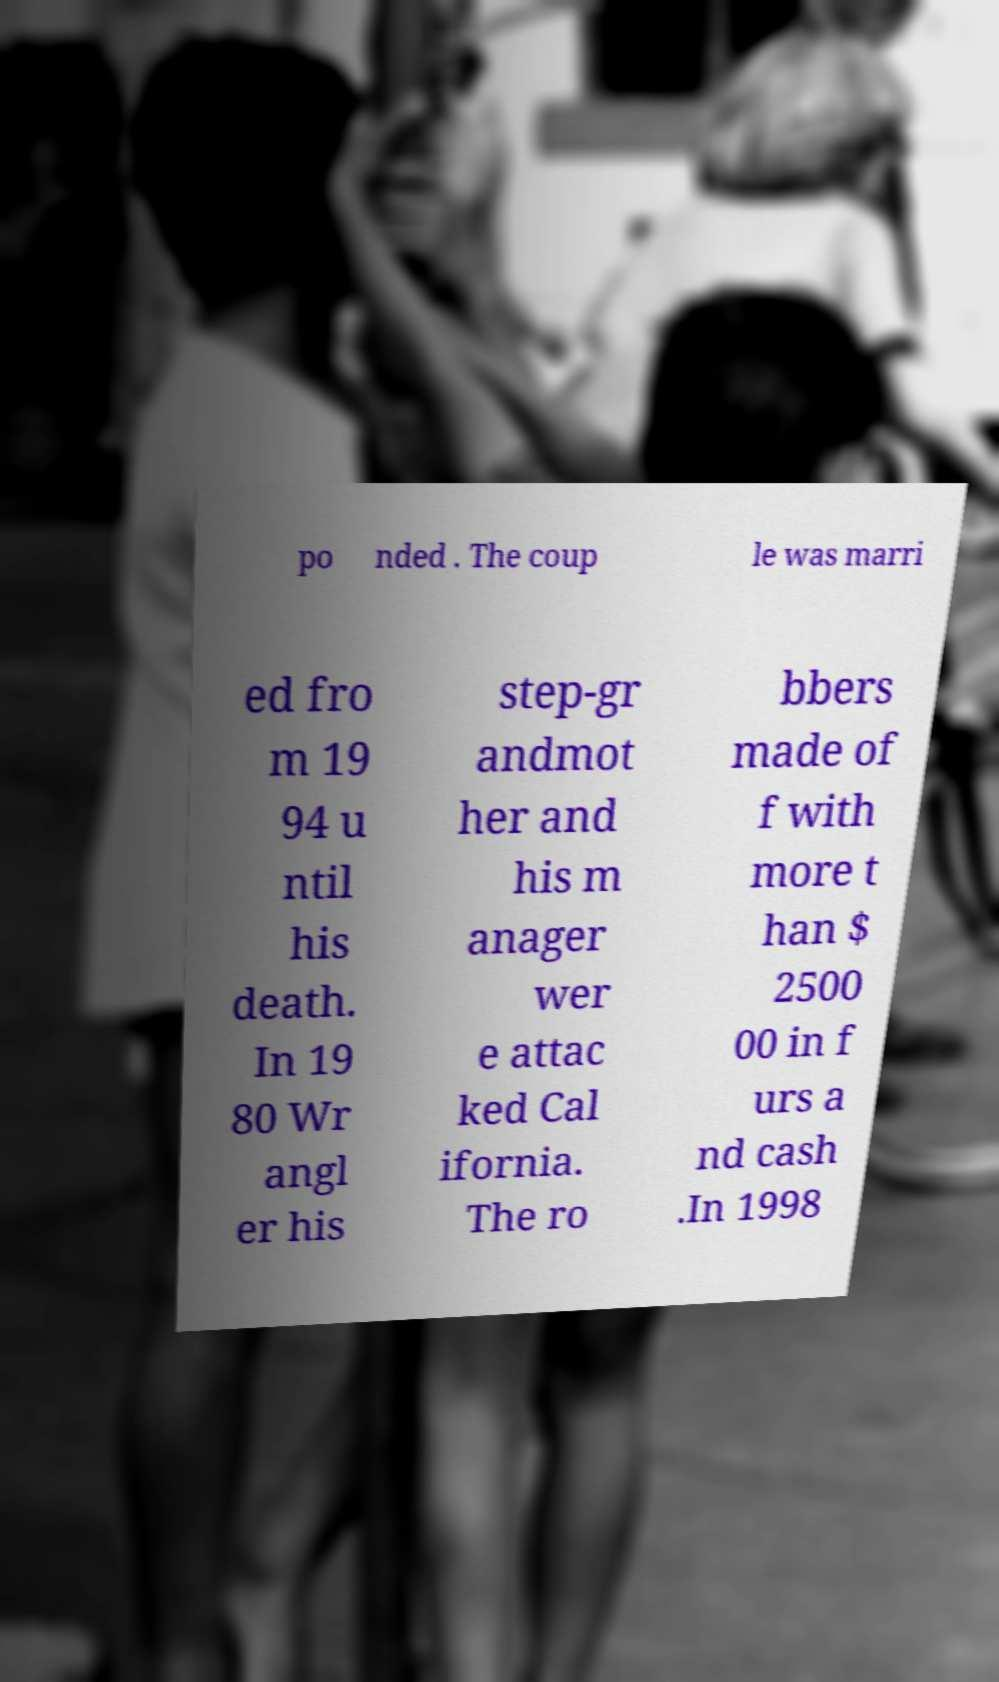For documentation purposes, I need the text within this image transcribed. Could you provide that? po nded . The coup le was marri ed fro m 19 94 u ntil his death. In 19 80 Wr angl er his step-gr andmot her and his m anager wer e attac ked Cal ifornia. The ro bbers made of f with more t han $ 2500 00 in f urs a nd cash .In 1998 